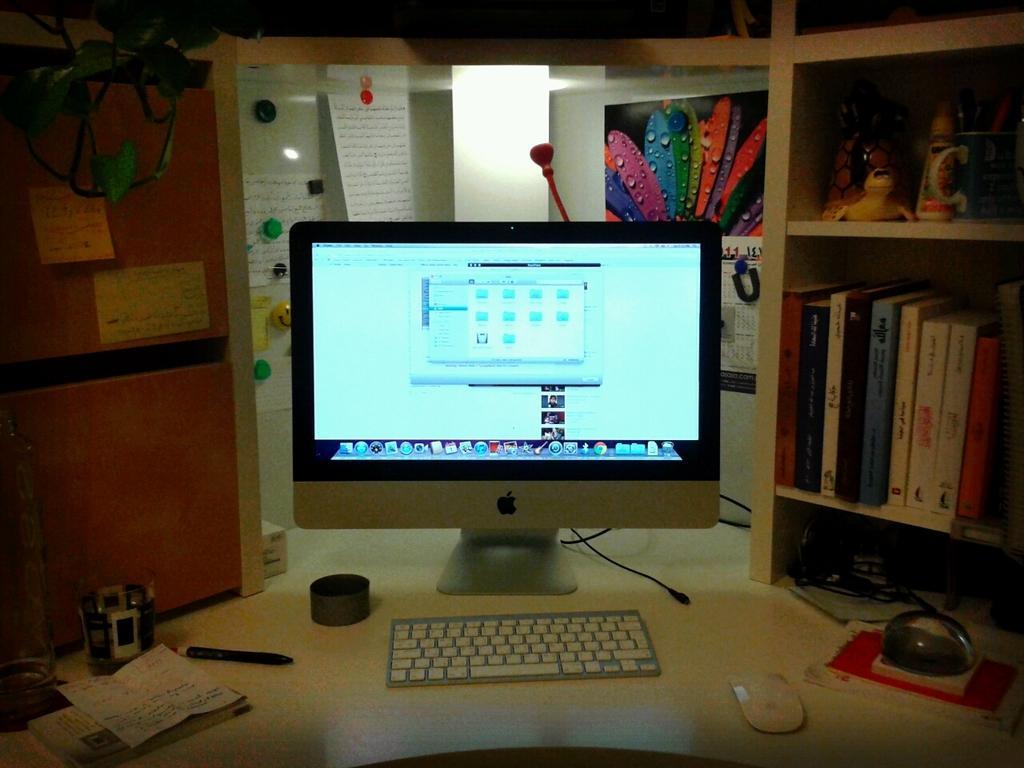Could you give a brief overview of what you see in this image? On the desk there is a monitor, keyboard, mouse, pen, paper, glass and a bottle. To the top left there is a plant. To the left there are books, toys and glue and also pens. Behind the monitor there are monitor and calendar. 